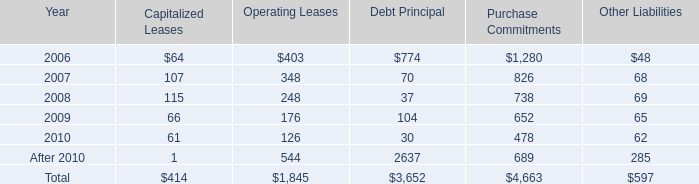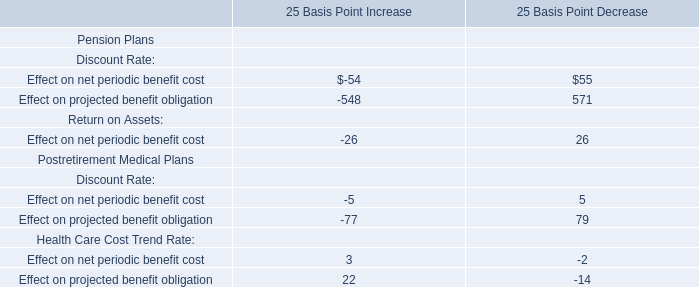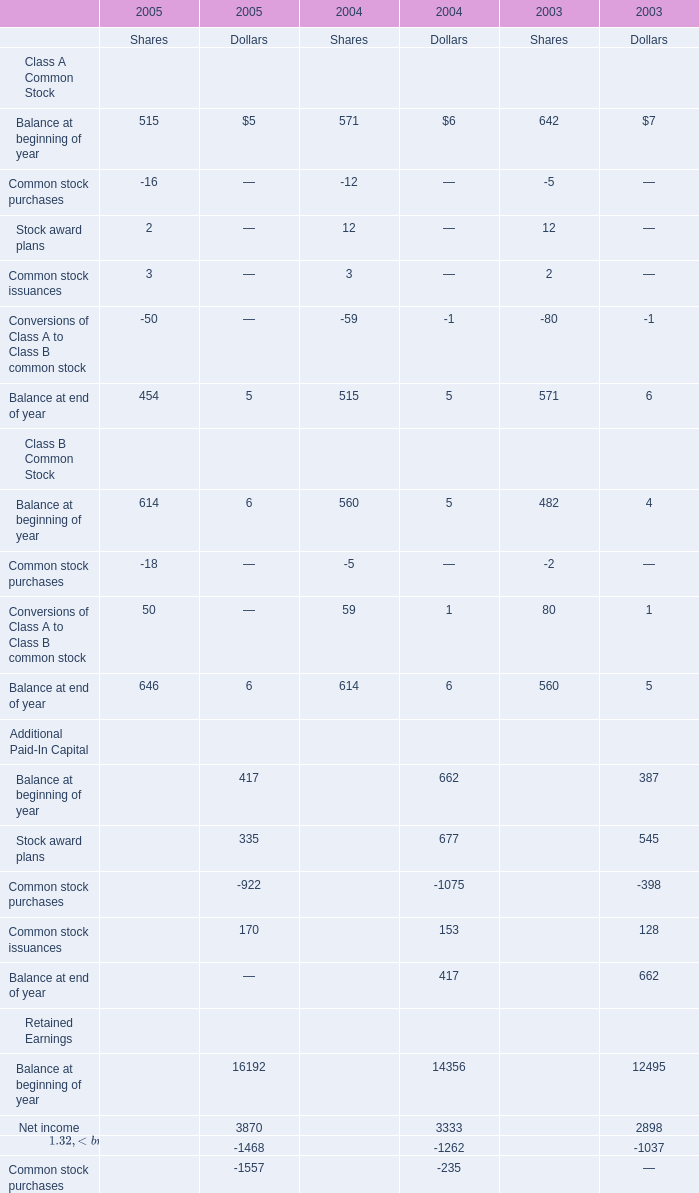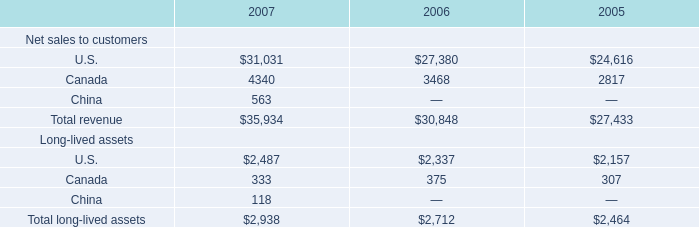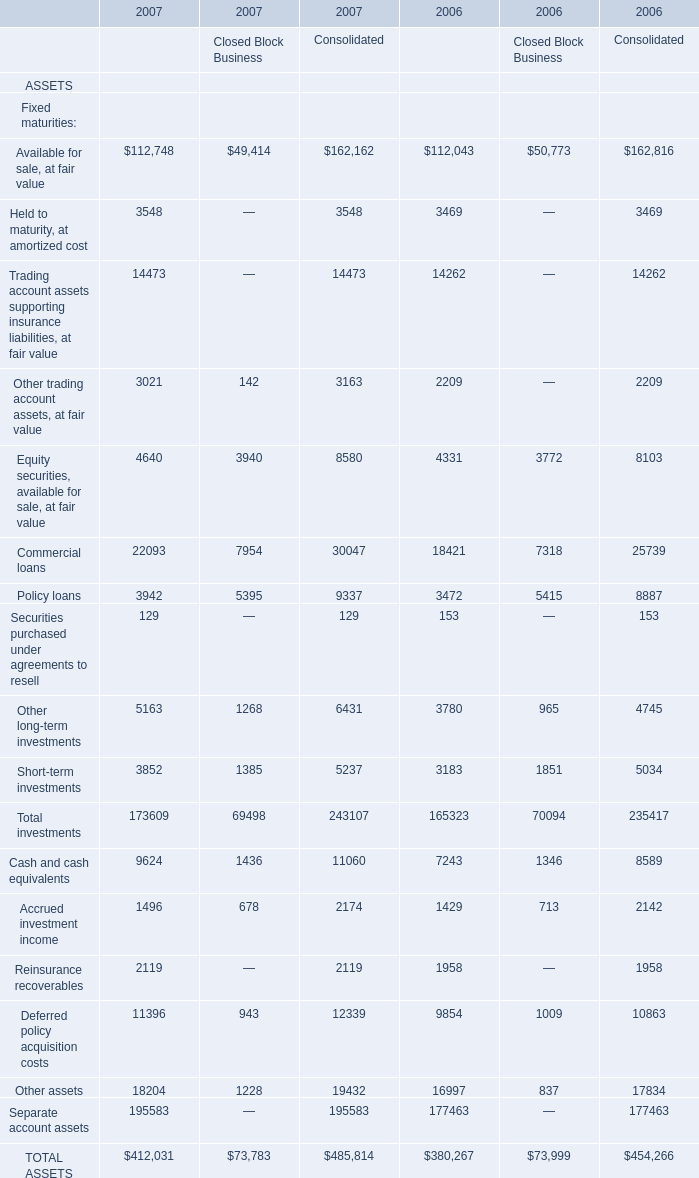What's the sum of all Shares that are greater than 0 in 2005? 
Computations: ((((515 + 2) + 3) + 614) + 50)
Answer: 1184.0. 